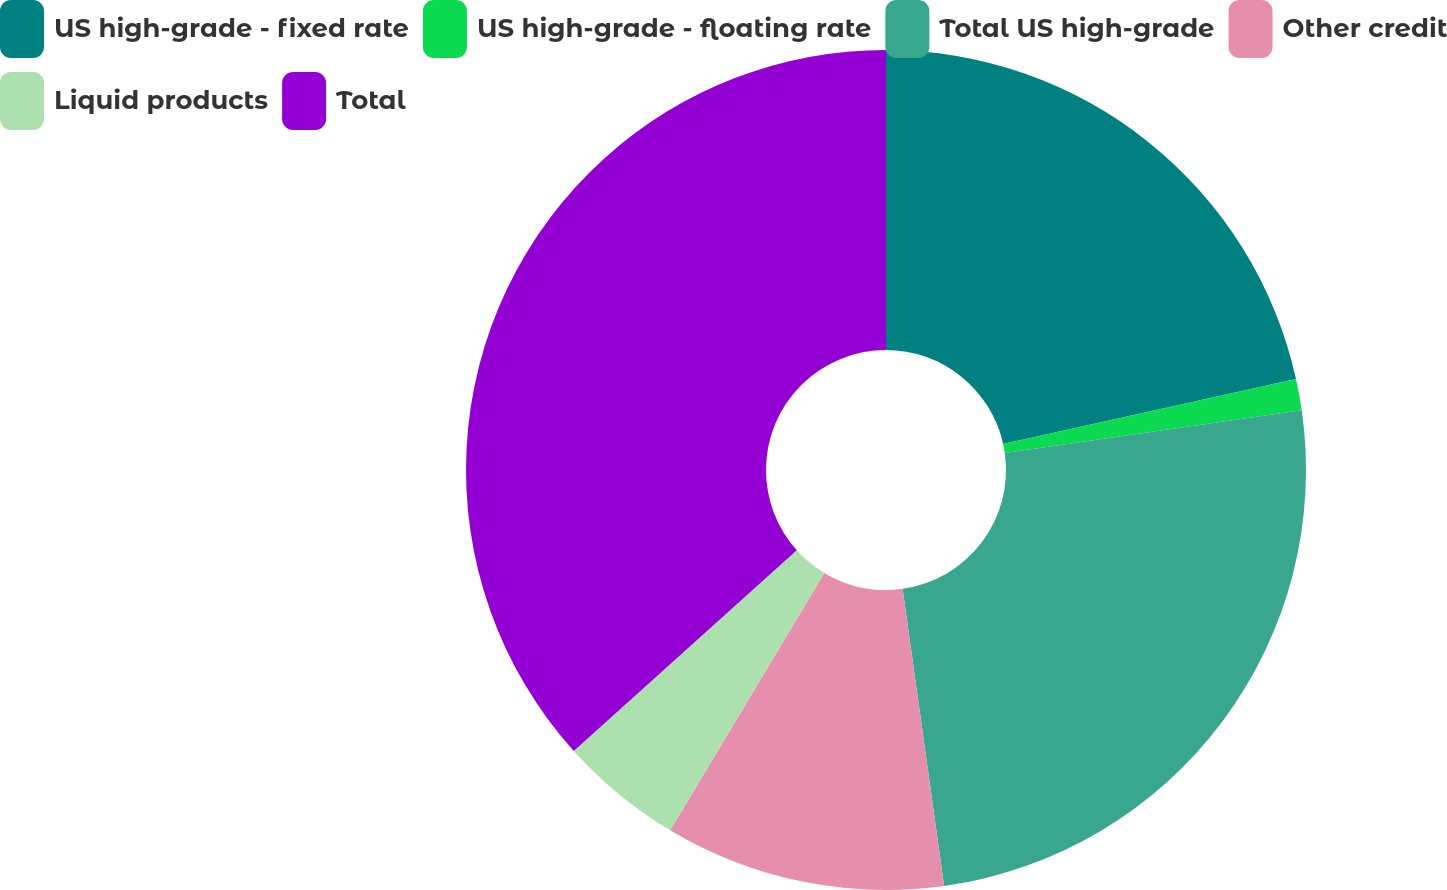<chart> <loc_0><loc_0><loc_500><loc_500><pie_chart><fcel>US high-grade - fixed rate<fcel>US high-grade - floating rate<fcel>Total US high-grade<fcel>Other credit<fcel>Liquid products<fcel>Total<nl><fcel>21.52%<fcel>1.21%<fcel>25.06%<fcel>10.8%<fcel>4.75%<fcel>36.66%<nl></chart> 